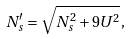Convert formula to latex. <formula><loc_0><loc_0><loc_500><loc_500>N ^ { \prime } _ { s } = \sqrt { N _ { s } ^ { 2 } + 9 U ^ { 2 } } \, ,</formula> 